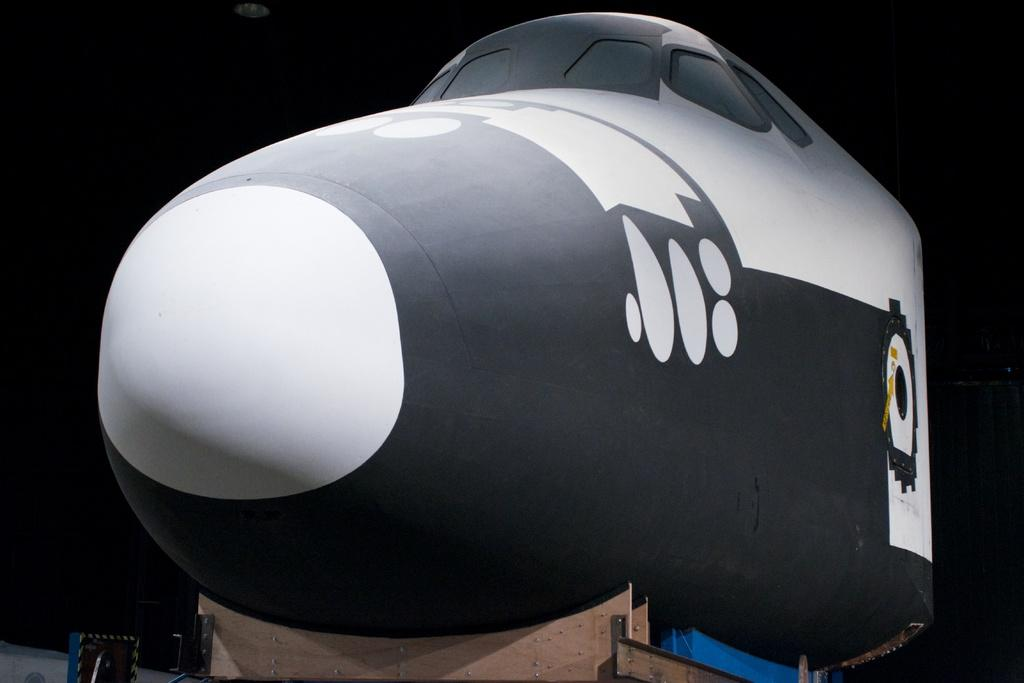What is the main subject of the image? There is a sculpture in the image. What can be seen at the bottom of the image? There are wooden blocks at the bottom of the image. What type of zinc material is used to create the sculpture in the image? There is no mention of zinc material being used in the sculpture; the image only provides information about the sculpture and wooden blocks. 